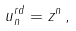<formula> <loc_0><loc_0><loc_500><loc_500>u _ { n } ^ { r d } = z ^ { n } \, ,</formula> 